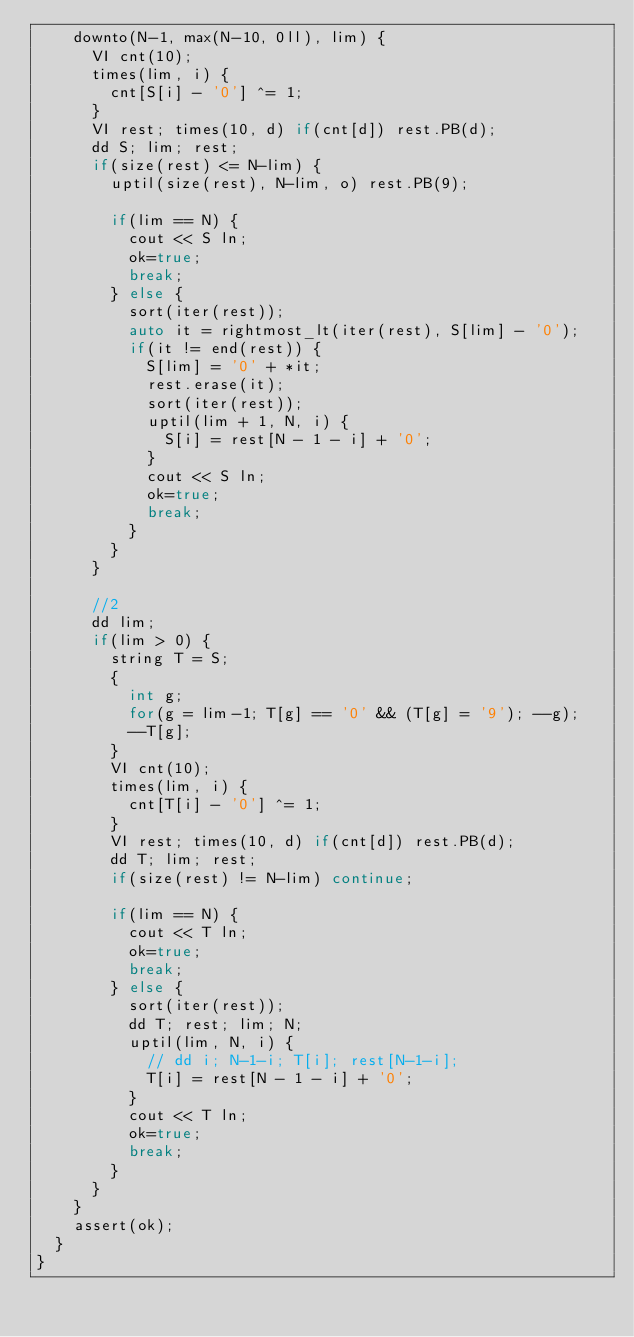Convert code to text. <code><loc_0><loc_0><loc_500><loc_500><_C++_>    downto(N-1, max(N-10, 0ll), lim) {
      VI cnt(10);
      times(lim, i) {
        cnt[S[i] - '0'] ^= 1;
      }
      VI rest; times(10, d) if(cnt[d]) rest.PB(d);
      dd S; lim; rest;
      if(size(rest) <= N-lim) {
        uptil(size(rest), N-lim, o) rest.PB(9);

        if(lim == N) {
          cout << S ln;
          ok=true;
          break;
        } else {
          sort(iter(rest));
          auto it = rightmost_lt(iter(rest), S[lim] - '0');
          if(it != end(rest)) {
            S[lim] = '0' + *it;
            rest.erase(it);
            sort(iter(rest));
            uptil(lim + 1, N, i) {
              S[i] = rest[N - 1 - i] + '0';
            }
            cout << S ln;
            ok=true;
            break;
          }
        }
      }

      //2
      dd lim;
      if(lim > 0) {
        string T = S;
        {
          int g;
          for(g = lim-1; T[g] == '0' && (T[g] = '9'); --g);
          --T[g];
        }
        VI cnt(10);
        times(lim, i) {
          cnt[T[i] - '0'] ^= 1;
        }
        VI rest; times(10, d) if(cnt[d]) rest.PB(d);
        dd T; lim; rest;
        if(size(rest) != N-lim) continue;

        if(lim == N) {
          cout << T ln;
          ok=true;
          break;
        } else {
          sort(iter(rest));
          dd T; rest; lim; N;
          uptil(lim, N, i) {
            // dd i; N-1-i; T[i]; rest[N-1-i];
            T[i] = rest[N - 1 - i] + '0';
          }
          cout << T ln;
          ok=true;
          break;
        }
      }
    }
    assert(ok);
  }
}
</code> 